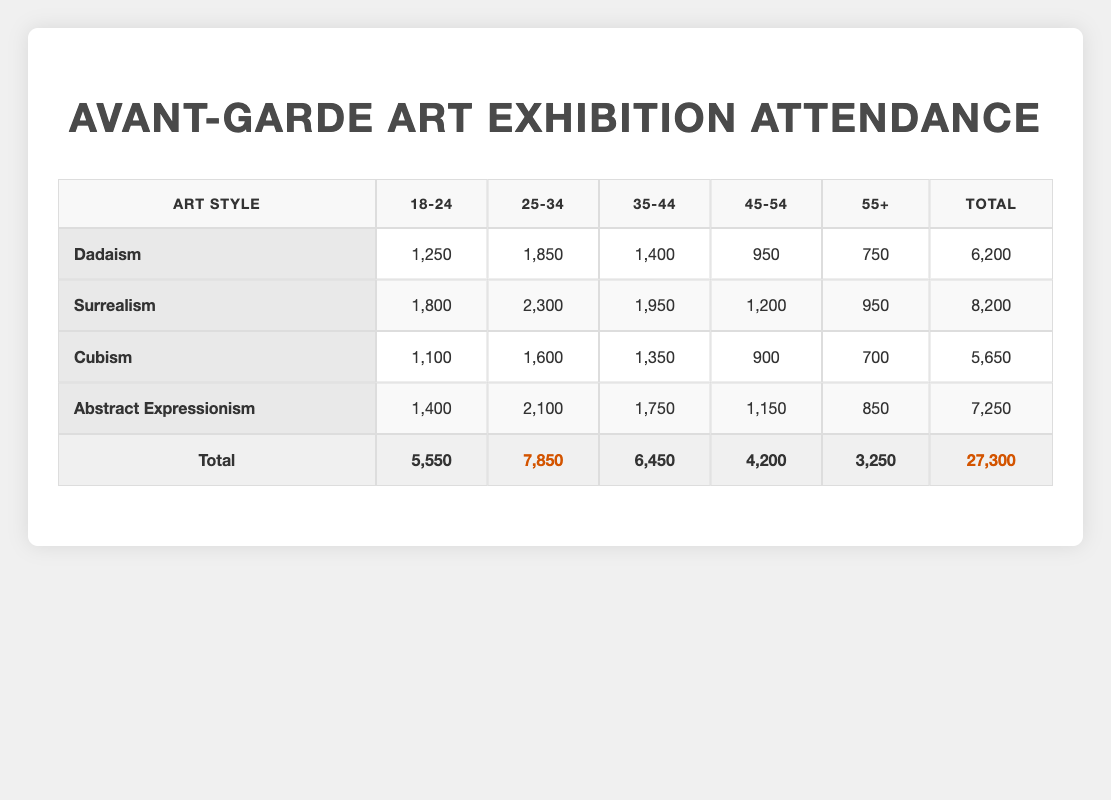What is the total attendance for the "Dadaism" exhibition? To find the total attendance for "Dadaism," I look at the corresponding row in the table. The values for the age groups (18-24: 1250, 25-34: 1850, 35-44: 1400, 45-54: 950, and 55+: 750) are summed up: 1250 + 1850 + 1400 + 950 + 750 = 6200.
Answer: 6200 Which age group had the highest attendance for the "Surrealism" exhibition? In the "Surrealism" row, I compare the attendance figures for each age group: 18-24: 1800, 25-34: 2300, 35-44: 1950, 45-54: 1200, and 55+: 950. The highest figure is 2300, corresponding to the 25-34 age group.
Answer: 25-34 Is the attendance for the "Abstract Expressionism" exhibition higher than that for "Cubism"? I check the total attendance for "Abstract Expressionism," which is 7250 and for "Cubism," which is 5650. Since 7250 is greater than 5650, the attendance for "Abstract Expressionism" is indeed higher than for "Cubism."
Answer: Yes What is the average attendance for the age group 55+ across all exhibitions? First, I extract the attendance values for the 55+ category from each row: Dadaism: 750, Surrealism: 950, Cubism: 700, and Abstract Expressionism: 850. I sum these values: 750 + 950 + 700 + 850 = 3250 and divide by the number of exhibitions (4): 3250 / 4 = 812.5.
Answer: 812.5 How many more attendees were there in the 25-34 age group compared to the 45-54 age group across all exhibitions? I first find the total attendance for both age groups: 25-34: Dadaism (1850) + Surrealism (2300) + Cubism (1600) + Abstract Expressionism (2100) = 7850. Then for the 45-54 age group: Dadaism (950) + Surrealism (1200) + Cubism (900) + Abstract Expressionism (1150) = 4200. I subtract these totals: 7850 - 4200 = 3650.
Answer: 3650 Which art style had the least total attendance? To determine this, I compare total attendances: Dadaism: 6200, Surrealism: 8200, Cubism: 5650, and Abstract Expressionism: 7250. Clearly, Cubism has the lowest total attendance of 5650.
Answer: Cubism 